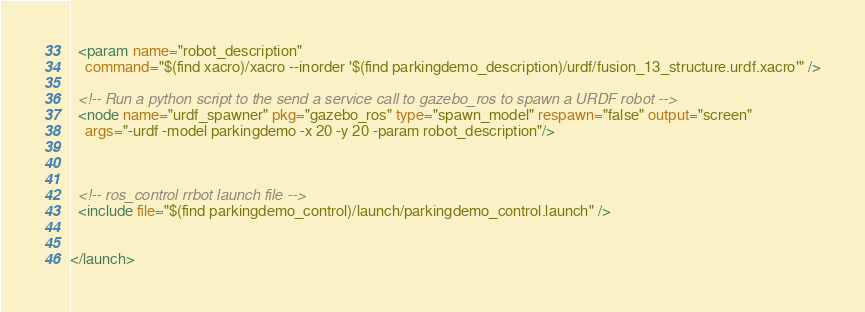Convert code to text. <code><loc_0><loc_0><loc_500><loc_500><_XML_>  <param name="robot_description"
    command="$(find xacro)/xacro --inorder '$(find parkingdemo_description)/urdf/fusion_13_structure.urdf.xacro'" />

  <!-- Run a python script to the send a service call to gazebo_ros to spawn a URDF robot -->
  <node name="urdf_spawner" pkg="gazebo_ros" type="spawn_model" respawn="false" output="screen"
    args="-urdf -model parkingdemo -x 20 -y 20 -param robot_description"/>

  

  <!-- ros_control rrbot launch file -->
  <include file="$(find parkingdemo_control)/launch/parkingdemo_control.launch" />


</launch>
</code> 